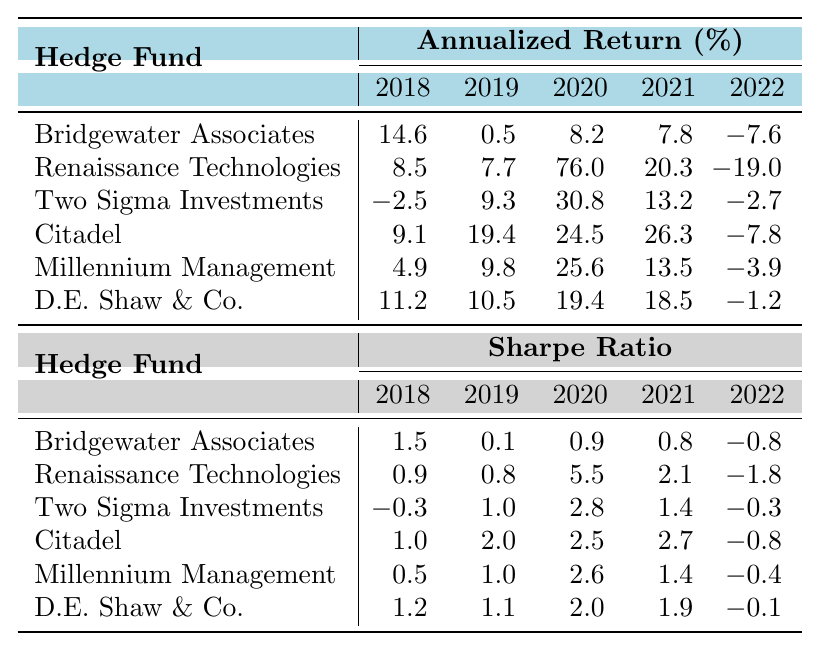What was the annualized return of Citadel in 2021? From the table, we can directly find the value corresponding to Citadel under the column for 2021, which shows 26.3%.
Answer: 26.3% Which hedge fund had the highest Sharpe ratio in 2020? Looking at the Sharpe ratio column for 2020, we can see that Renaissance Technologies has the highest value listed, which is 5.5.
Answer: Renaissance Technologies What is the average annualized return of Millennium Management from 2018 to 2022? First, we extract the values of Millennium Management for those years: 4.9, 9.8, 25.6, 13.5, and -3.9. Then, we sum these values (4.9 + 9.8 + 25.6 + 13.5 - 3.9 = 50.9) and divide by the number of years (5), resulting in an average of 10.18%.
Answer: 10.18% Did Two Sigma Investments have a negative annualized return any year from 2013 to 2022? We can examine the annualized return values for Two Sigma Investments across all years listed. In 2016 and 2018, the values are -2.5 and -2.7 respectively, confirming that there were negative returns.
Answer: Yes Which hedge fund showed the greatest improvement in annualized return from 2018 to 2019? We look at the annualized returns for each hedge fund in 2018 and 2019. The improvements are: Bridgewater Associates (from 14.6 to 0.5), Renaissance Technologies (from 8.5 to 7.7), Two Sigma Investments (from -2.5 to 9.3), Citadel (from 9.1 to 19.4), Millennium Management (from 4.9 to 9.8), and D.E. Shaw & Co. (from 11.2 to 10.5). The greatest improvement is seen with Two Sigma Investments, which increased by 11.8%.
Answer: Two Sigma Investments Which hedge fund consistently had a positive Sharpe ratio from 2018 to 2020? Reviewing the data for each hedge fund under the Sharpe ratio from 2018 to 2020, we find that Citadel maintains positive values for all three years (1.0, 2.0, 2.5). Other hedge funds either drop below zero or show inconsistency.
Answer: Citadel What was the total annualized return of D.E. Shaw & Co. for 2019 and 2020? We add the annualized return values for 2019 (10.5) and 2020 (19.4) for D.E. Shaw & Co. The total is 10.5 + 19.4 = 29.9%.
Answer: 29.9% Which hedge fund had the lowest Sharpe ratio in 2022? Checking the Sharpe ratio values for 2022, we identify that Bridgewater Associates had the lowest Sharpe ratio, which is -0.8, in comparison with other hedge funds listed for that year.
Answer: Bridgewater Associates What was the difference in annualized return between Renaissance Technologies in 2019 and 2020? By looking at the annualized return values, we see that Renaissance Technologies had 7.7 in 2019 and 76.0 in 2020. The difference is 76.0 - 7.7 = 68.3.
Answer: 68.3 Which hedge fund's average annualized return is the highest from 2018 to 2022? We calculate the average annualized returns for each hedge fund for those years. The averages are: Bridgewater Associates (6.0), Renaissance Technologies (3.5), Two Sigma Investments (9.8), Citadel (18.5), Millennium Management (9.0), and D.E. Shaw & Co. (15.6). Citadel has the highest average of 18.5.
Answer: Citadel 